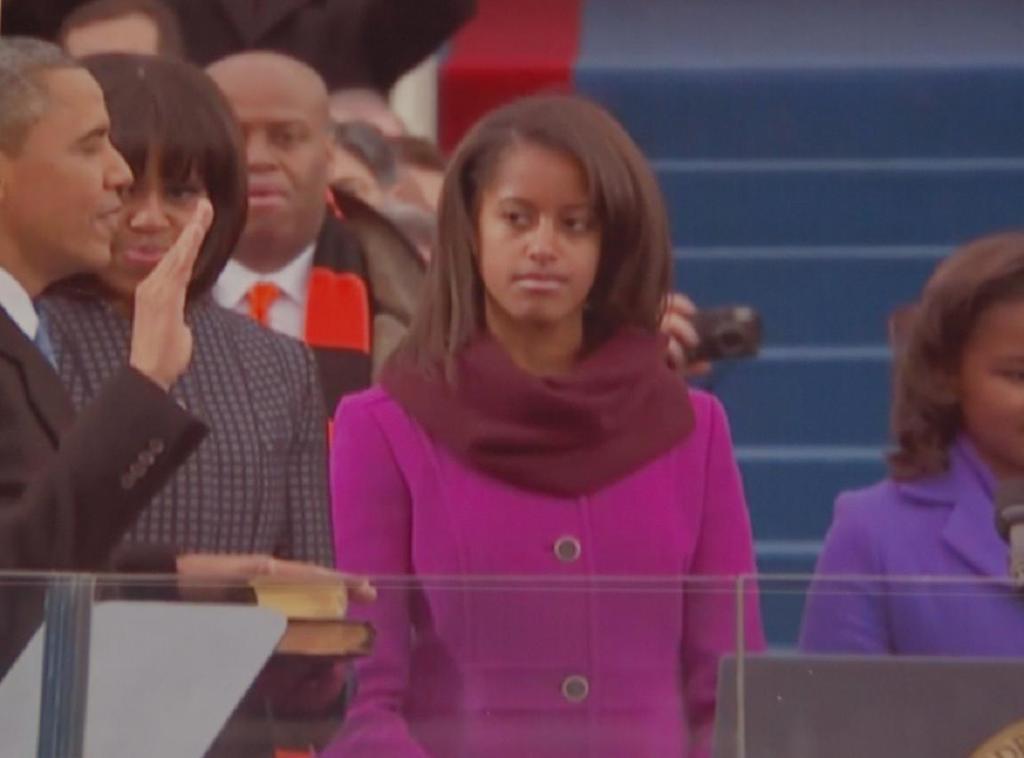Can you describe this image briefly? In the image I can see people are standing. In the background I can see steps and other objects. 